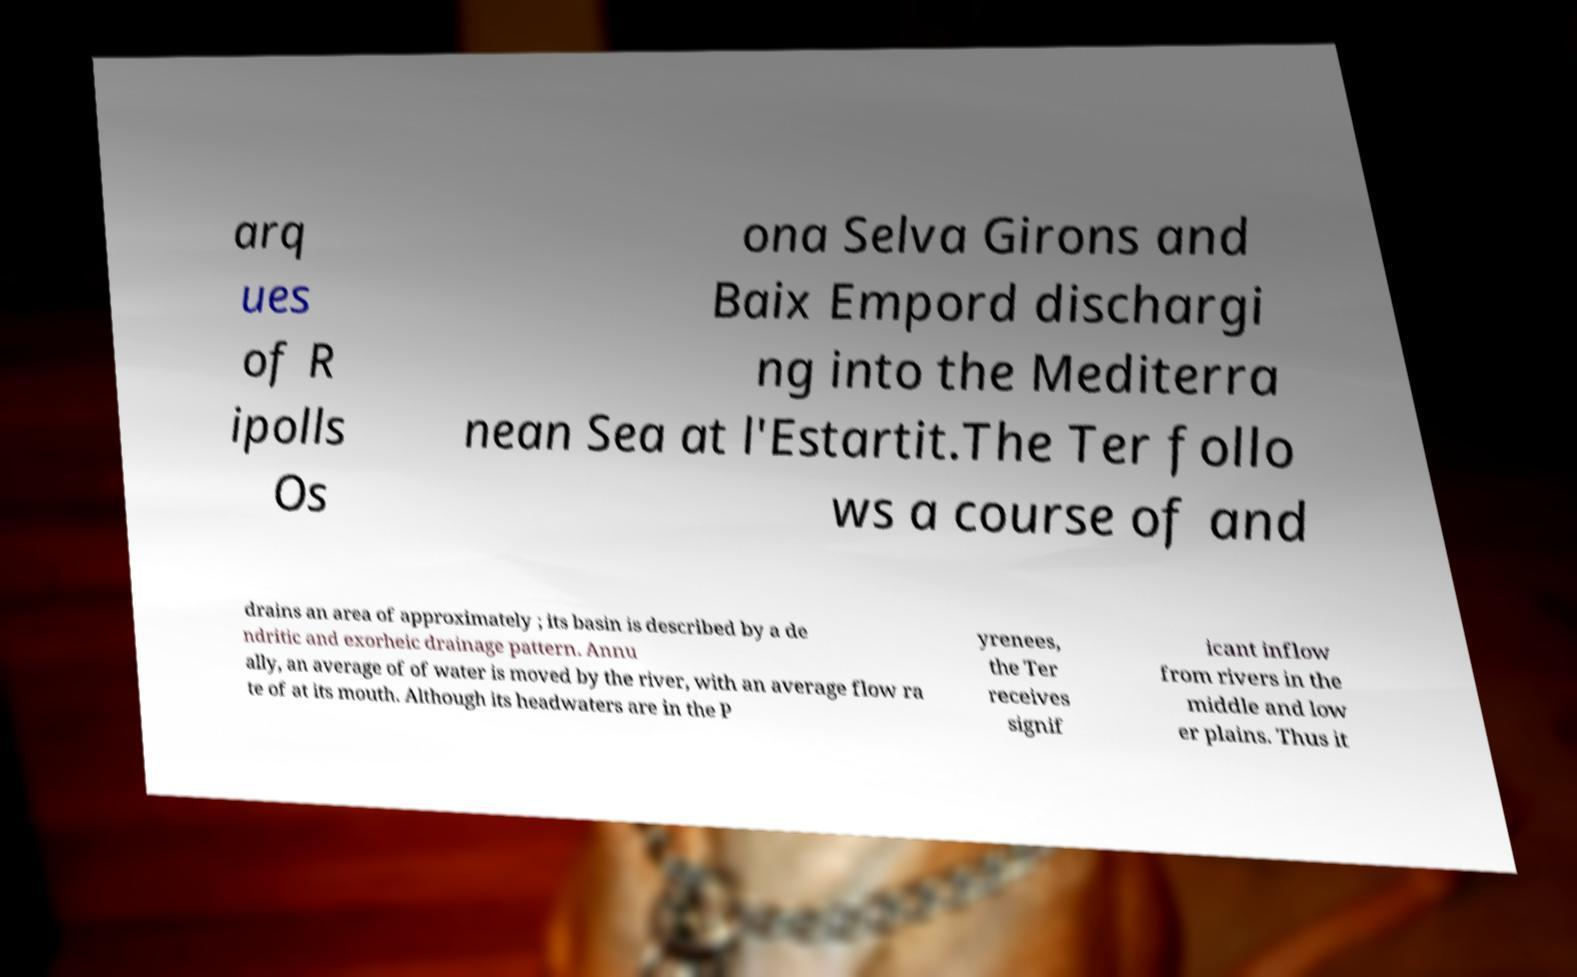Can you accurately transcribe the text from the provided image for me? arq ues of R ipolls Os ona Selva Girons and Baix Empord dischargi ng into the Mediterra nean Sea at l'Estartit.The Ter follo ws a course of and drains an area of approximately ; its basin is described by a de ndritic and exorheic drainage pattern. Annu ally, an average of of water is moved by the river, with an average flow ra te of at its mouth. Although its headwaters are in the P yrenees, the Ter receives signif icant inflow from rivers in the middle and low er plains. Thus it 